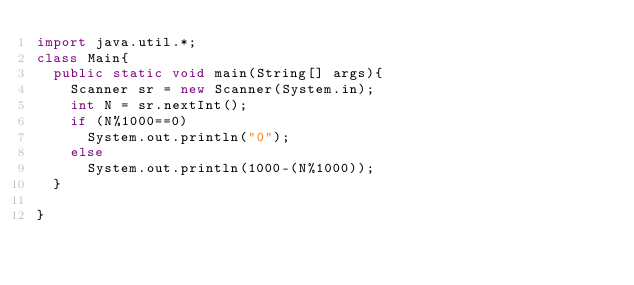<code> <loc_0><loc_0><loc_500><loc_500><_Java_>import java.util.*;
class Main{
  public static void main(String[] args){
    Scanner sr = new Scanner(System.in);
    int N = sr.nextInt();
    if (N%1000==0)
      System.out.println("0");
    else
      System.out.println(1000-(N%1000));
  }

}</code> 